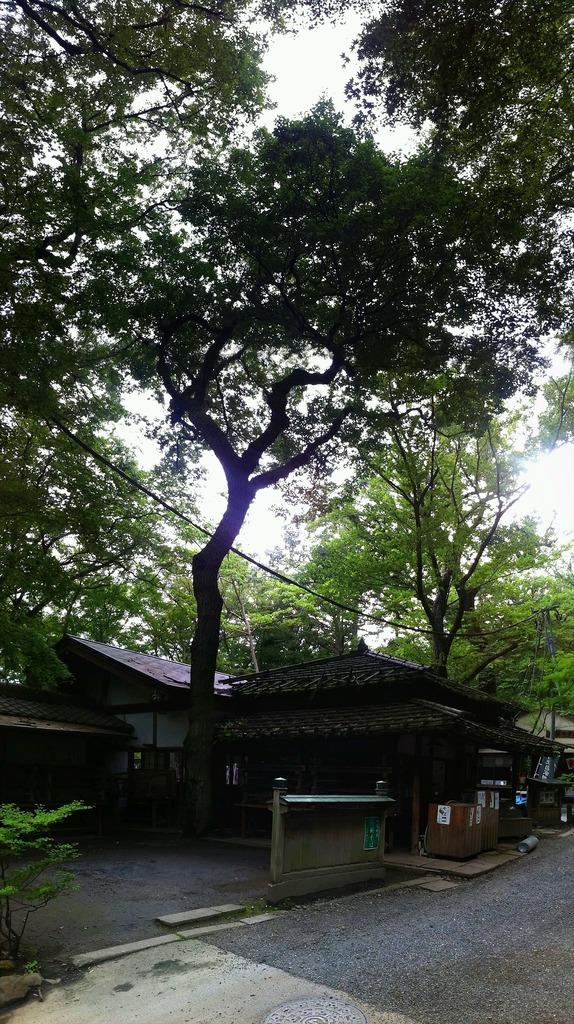What type of structures are visible in the image? There are houses in the image. What other natural elements can be seen in the image? There are trees in the image. What is located in front of the houses? There are objects in front of the houses. Where is a plant located in the image? The plant is in the bottom left of the image. What is visible at the top of the image? The sky is visible at the top of the image. Can you see a dog smashing toys in the image? No, there is no dog or smashed toys present in the image. 